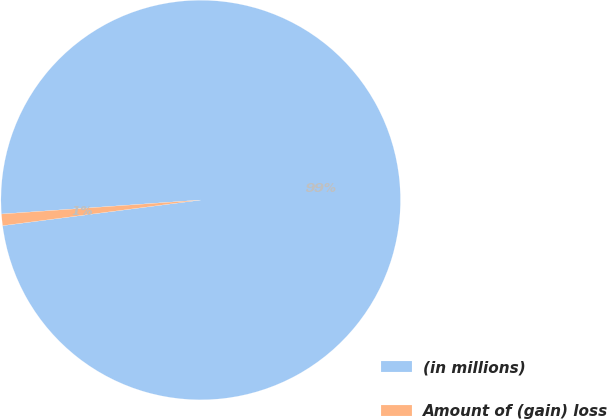Convert chart. <chart><loc_0><loc_0><loc_500><loc_500><pie_chart><fcel>(in millions)<fcel>Amount of (gain) loss<nl><fcel>99.07%<fcel>0.93%<nl></chart> 